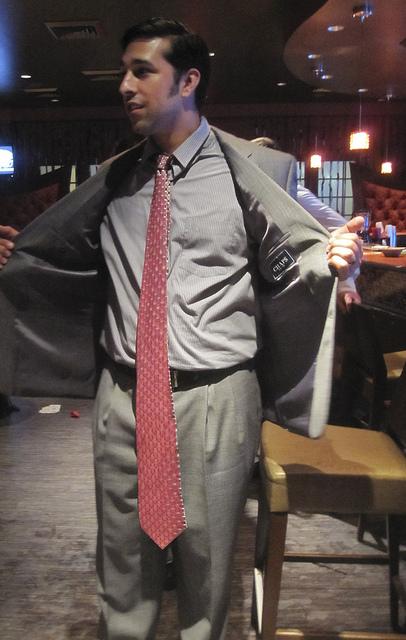What kind of knot is used on the tie?
Write a very short answer. Windsor. What is unusual about this man's clothing?
Be succinct. Long tie. What is the person wearing?
Answer briefly. Suit. Is the man about to hug someone?
Quick response, please. No. Does the man have a gun?
Quick response, please. No. 